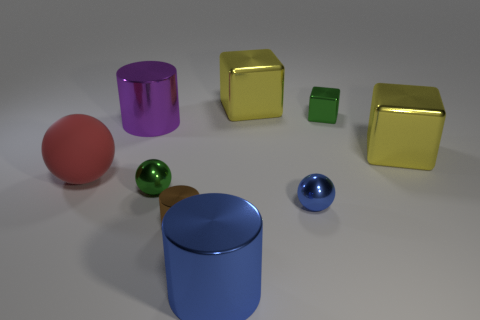Add 1 small blue metal spheres. How many objects exist? 10 Subtract all cylinders. How many objects are left? 6 Add 6 large red rubber objects. How many large red rubber objects are left? 7 Add 9 purple matte cylinders. How many purple matte cylinders exist? 9 Subtract 0 yellow cylinders. How many objects are left? 9 Subtract all green shiny cubes. Subtract all green metal spheres. How many objects are left? 7 